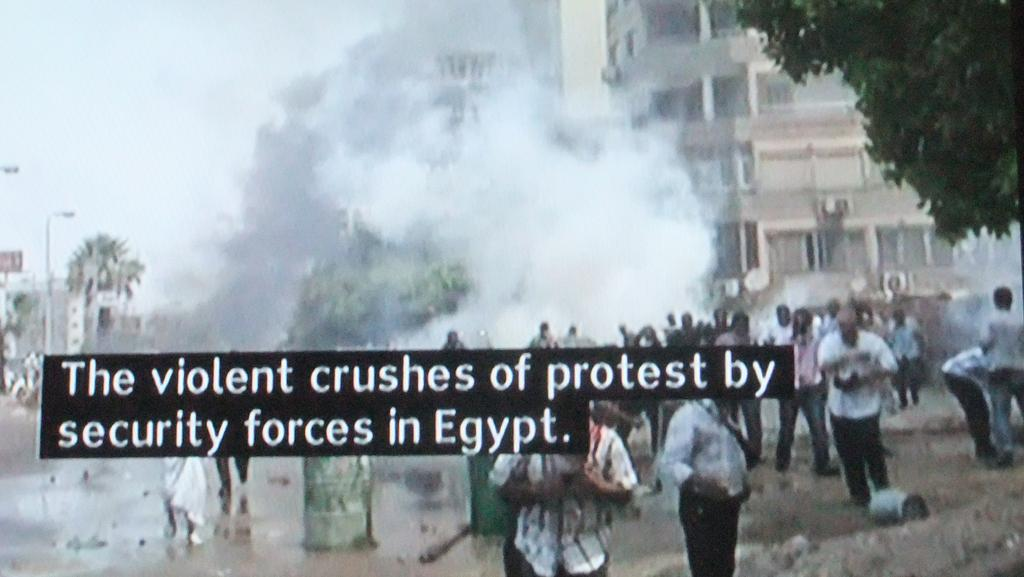How many people are in the image? There is a group of people in the image. What are the people in the image doing? Some people are standing, while others are walking. What type of surface is visible in the image? There is ground visible in the image. What type of vegetation is present in the image? Trees are present in the image. What type of structures can be seen in the image? There are buildings with windows in the image. What is the source of the smoke in the image? The source of the smoke is not specified in the image. What is visible in the sky in the image? The sky is visible in the image. What type of information is provided on the image? There is text on the image. How many secretaries are present in the image? There is no mention of secretaries in the image. What type of clothing are the servants wearing in the image? There is no mention of servants in the image. 